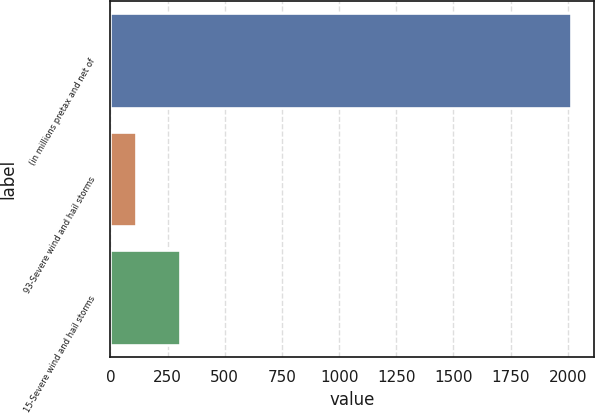Convert chart to OTSL. <chart><loc_0><loc_0><loc_500><loc_500><bar_chart><fcel>(in millions pretax and net of<fcel>93-Severe wind and hail storms<fcel>15-Severe wind and hail storms<nl><fcel>2013<fcel>114<fcel>303.9<nl></chart> 